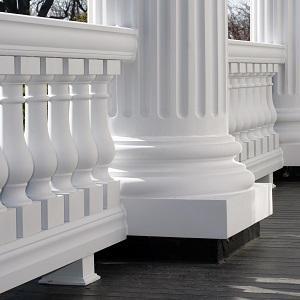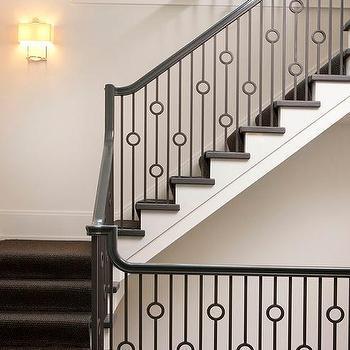The first image is the image on the left, the second image is the image on the right. Given the left and right images, does the statement "One image features a staircase that takes a turn to the right and has dark rails with vertical wrought iron bars accented with circle shapes." hold true? Answer yes or no. Yes. 